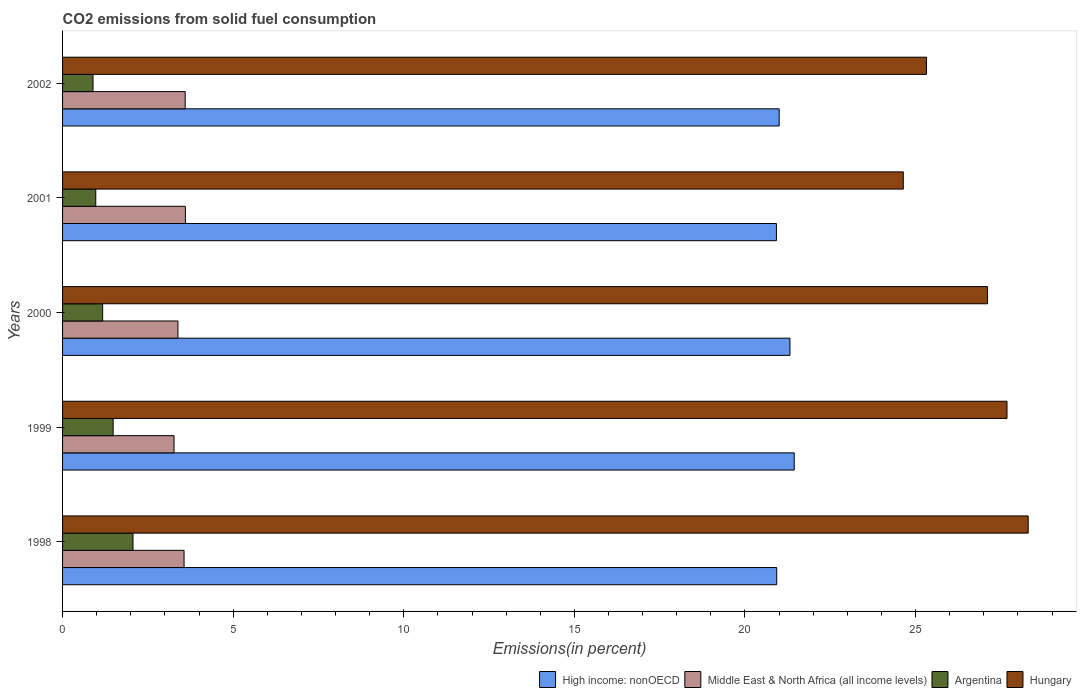In how many cases, is the number of bars for a given year not equal to the number of legend labels?
Offer a very short reply. 0. What is the total CO2 emitted in Argentina in 1998?
Offer a terse response. 2.06. Across all years, what is the maximum total CO2 emitted in Hungary?
Ensure brevity in your answer.  28.3. Across all years, what is the minimum total CO2 emitted in Middle East & North Africa (all income levels)?
Keep it short and to the point. 3.27. In which year was the total CO2 emitted in Argentina maximum?
Ensure brevity in your answer.  1998. In which year was the total CO2 emitted in Middle East & North Africa (all income levels) minimum?
Provide a succinct answer. 1999. What is the total total CO2 emitted in Hungary in the graph?
Offer a very short reply. 133.05. What is the difference between the total CO2 emitted in Hungary in 1998 and that in 2000?
Provide a succinct answer. 1.19. What is the difference between the total CO2 emitted in High income: nonOECD in 1999 and the total CO2 emitted in Middle East & North Africa (all income levels) in 2002?
Your answer should be very brief. 17.85. What is the average total CO2 emitted in Middle East & North Africa (all income levels) per year?
Your answer should be very brief. 3.48. In the year 1998, what is the difference between the total CO2 emitted in Middle East & North Africa (all income levels) and total CO2 emitted in Argentina?
Offer a very short reply. 1.5. In how many years, is the total CO2 emitted in Middle East & North Africa (all income levels) greater than 11 %?
Your answer should be compact. 0. What is the ratio of the total CO2 emitted in Argentina in 1998 to that in 2001?
Your answer should be very brief. 2.12. Is the total CO2 emitted in Argentina in 1998 less than that in 2002?
Offer a very short reply. No. What is the difference between the highest and the second highest total CO2 emitted in Middle East & North Africa (all income levels)?
Offer a terse response. 0.01. What is the difference between the highest and the lowest total CO2 emitted in High income: nonOECD?
Your response must be concise. 0.52. Is it the case that in every year, the sum of the total CO2 emitted in Hungary and total CO2 emitted in Middle East & North Africa (all income levels) is greater than the sum of total CO2 emitted in High income: nonOECD and total CO2 emitted in Argentina?
Provide a short and direct response. Yes. What does the 4th bar from the top in 2000 represents?
Offer a terse response. High income: nonOECD. What does the 2nd bar from the bottom in 1998 represents?
Offer a terse response. Middle East & North Africa (all income levels). Are all the bars in the graph horizontal?
Make the answer very short. Yes. How many years are there in the graph?
Offer a very short reply. 5. Are the values on the major ticks of X-axis written in scientific E-notation?
Your answer should be very brief. No. Does the graph contain any zero values?
Keep it short and to the point. No. Does the graph contain grids?
Provide a short and direct response. No. How many legend labels are there?
Your response must be concise. 4. What is the title of the graph?
Your answer should be very brief. CO2 emissions from solid fuel consumption. What is the label or title of the X-axis?
Provide a succinct answer. Emissions(in percent). What is the Emissions(in percent) of High income: nonOECD in 1998?
Provide a short and direct response. 20.93. What is the Emissions(in percent) of Middle East & North Africa (all income levels) in 1998?
Provide a succinct answer. 3.56. What is the Emissions(in percent) in Argentina in 1998?
Offer a terse response. 2.06. What is the Emissions(in percent) in Hungary in 1998?
Keep it short and to the point. 28.3. What is the Emissions(in percent) of High income: nonOECD in 1999?
Give a very brief answer. 21.44. What is the Emissions(in percent) of Middle East & North Africa (all income levels) in 1999?
Ensure brevity in your answer.  3.27. What is the Emissions(in percent) in Argentina in 1999?
Offer a very short reply. 1.48. What is the Emissions(in percent) of Hungary in 1999?
Offer a very short reply. 27.68. What is the Emissions(in percent) in High income: nonOECD in 2000?
Provide a succinct answer. 21.32. What is the Emissions(in percent) of Middle East & North Africa (all income levels) in 2000?
Your answer should be very brief. 3.38. What is the Emissions(in percent) in Argentina in 2000?
Ensure brevity in your answer.  1.17. What is the Emissions(in percent) of Hungary in 2000?
Keep it short and to the point. 27.11. What is the Emissions(in percent) in High income: nonOECD in 2001?
Offer a terse response. 20.92. What is the Emissions(in percent) in Middle East & North Africa (all income levels) in 2001?
Make the answer very short. 3.6. What is the Emissions(in percent) in Argentina in 2001?
Give a very brief answer. 0.97. What is the Emissions(in percent) of Hungary in 2001?
Offer a very short reply. 24.64. What is the Emissions(in percent) in High income: nonOECD in 2002?
Offer a terse response. 21. What is the Emissions(in percent) in Middle East & North Africa (all income levels) in 2002?
Give a very brief answer. 3.59. What is the Emissions(in percent) of Argentina in 2002?
Offer a terse response. 0.89. What is the Emissions(in percent) in Hungary in 2002?
Ensure brevity in your answer.  25.32. Across all years, what is the maximum Emissions(in percent) in High income: nonOECD?
Provide a succinct answer. 21.44. Across all years, what is the maximum Emissions(in percent) in Middle East & North Africa (all income levels)?
Offer a very short reply. 3.6. Across all years, what is the maximum Emissions(in percent) of Argentina?
Make the answer very short. 2.06. Across all years, what is the maximum Emissions(in percent) in Hungary?
Provide a succinct answer. 28.3. Across all years, what is the minimum Emissions(in percent) of High income: nonOECD?
Your answer should be compact. 20.92. Across all years, what is the minimum Emissions(in percent) of Middle East & North Africa (all income levels)?
Give a very brief answer. 3.27. Across all years, what is the minimum Emissions(in percent) of Argentina?
Ensure brevity in your answer.  0.89. Across all years, what is the minimum Emissions(in percent) of Hungary?
Provide a short and direct response. 24.64. What is the total Emissions(in percent) in High income: nonOECD in the graph?
Ensure brevity in your answer.  105.61. What is the total Emissions(in percent) of Middle East & North Africa (all income levels) in the graph?
Offer a terse response. 17.4. What is the total Emissions(in percent) of Argentina in the graph?
Provide a succinct answer. 6.59. What is the total Emissions(in percent) in Hungary in the graph?
Your response must be concise. 133.05. What is the difference between the Emissions(in percent) in High income: nonOECD in 1998 and that in 1999?
Your response must be concise. -0.51. What is the difference between the Emissions(in percent) in Middle East & North Africa (all income levels) in 1998 and that in 1999?
Offer a terse response. 0.29. What is the difference between the Emissions(in percent) of Argentina in 1998 and that in 1999?
Offer a very short reply. 0.58. What is the difference between the Emissions(in percent) in Hungary in 1998 and that in 1999?
Your response must be concise. 0.62. What is the difference between the Emissions(in percent) of High income: nonOECD in 1998 and that in 2000?
Give a very brief answer. -0.39. What is the difference between the Emissions(in percent) in Middle East & North Africa (all income levels) in 1998 and that in 2000?
Offer a terse response. 0.18. What is the difference between the Emissions(in percent) in Argentina in 1998 and that in 2000?
Give a very brief answer. 0.89. What is the difference between the Emissions(in percent) of Hungary in 1998 and that in 2000?
Offer a terse response. 1.19. What is the difference between the Emissions(in percent) of High income: nonOECD in 1998 and that in 2001?
Make the answer very short. 0.01. What is the difference between the Emissions(in percent) in Middle East & North Africa (all income levels) in 1998 and that in 2001?
Offer a terse response. -0.04. What is the difference between the Emissions(in percent) in Argentina in 1998 and that in 2001?
Ensure brevity in your answer.  1.09. What is the difference between the Emissions(in percent) in Hungary in 1998 and that in 2001?
Provide a succinct answer. 3.66. What is the difference between the Emissions(in percent) of High income: nonOECD in 1998 and that in 2002?
Make the answer very short. -0.07. What is the difference between the Emissions(in percent) of Middle East & North Africa (all income levels) in 1998 and that in 2002?
Give a very brief answer. -0.03. What is the difference between the Emissions(in percent) in Argentina in 1998 and that in 2002?
Your response must be concise. 1.17. What is the difference between the Emissions(in percent) in Hungary in 1998 and that in 2002?
Keep it short and to the point. 2.98. What is the difference between the Emissions(in percent) of High income: nonOECD in 1999 and that in 2000?
Your answer should be very brief. 0.13. What is the difference between the Emissions(in percent) of Middle East & North Africa (all income levels) in 1999 and that in 2000?
Your answer should be compact. -0.11. What is the difference between the Emissions(in percent) in Argentina in 1999 and that in 2000?
Keep it short and to the point. 0.31. What is the difference between the Emissions(in percent) in Hungary in 1999 and that in 2000?
Make the answer very short. 0.57. What is the difference between the Emissions(in percent) of High income: nonOECD in 1999 and that in 2001?
Provide a short and direct response. 0.52. What is the difference between the Emissions(in percent) in Middle East & North Africa (all income levels) in 1999 and that in 2001?
Offer a very short reply. -0.33. What is the difference between the Emissions(in percent) of Argentina in 1999 and that in 2001?
Offer a terse response. 0.51. What is the difference between the Emissions(in percent) of Hungary in 1999 and that in 2001?
Offer a very short reply. 3.04. What is the difference between the Emissions(in percent) of High income: nonOECD in 1999 and that in 2002?
Give a very brief answer. 0.44. What is the difference between the Emissions(in percent) in Middle East & North Africa (all income levels) in 1999 and that in 2002?
Provide a short and direct response. -0.33. What is the difference between the Emissions(in percent) in Argentina in 1999 and that in 2002?
Your answer should be compact. 0.59. What is the difference between the Emissions(in percent) of Hungary in 1999 and that in 2002?
Provide a succinct answer. 2.36. What is the difference between the Emissions(in percent) in High income: nonOECD in 2000 and that in 2001?
Your answer should be compact. 0.4. What is the difference between the Emissions(in percent) in Middle East & North Africa (all income levels) in 2000 and that in 2001?
Offer a very short reply. -0.22. What is the difference between the Emissions(in percent) in Argentina in 2000 and that in 2001?
Make the answer very short. 0.2. What is the difference between the Emissions(in percent) of Hungary in 2000 and that in 2001?
Give a very brief answer. 2.47. What is the difference between the Emissions(in percent) in High income: nonOECD in 2000 and that in 2002?
Keep it short and to the point. 0.32. What is the difference between the Emissions(in percent) in Middle East & North Africa (all income levels) in 2000 and that in 2002?
Your response must be concise. -0.21. What is the difference between the Emissions(in percent) in Argentina in 2000 and that in 2002?
Your answer should be compact. 0.28. What is the difference between the Emissions(in percent) of Hungary in 2000 and that in 2002?
Make the answer very short. 1.79. What is the difference between the Emissions(in percent) in High income: nonOECD in 2001 and that in 2002?
Offer a very short reply. -0.08. What is the difference between the Emissions(in percent) of Middle East & North Africa (all income levels) in 2001 and that in 2002?
Make the answer very short. 0.01. What is the difference between the Emissions(in percent) in Argentina in 2001 and that in 2002?
Give a very brief answer. 0.08. What is the difference between the Emissions(in percent) of Hungary in 2001 and that in 2002?
Ensure brevity in your answer.  -0.68. What is the difference between the Emissions(in percent) in High income: nonOECD in 1998 and the Emissions(in percent) in Middle East & North Africa (all income levels) in 1999?
Make the answer very short. 17.66. What is the difference between the Emissions(in percent) of High income: nonOECD in 1998 and the Emissions(in percent) of Argentina in 1999?
Keep it short and to the point. 19.45. What is the difference between the Emissions(in percent) in High income: nonOECD in 1998 and the Emissions(in percent) in Hungary in 1999?
Make the answer very short. -6.75. What is the difference between the Emissions(in percent) in Middle East & North Africa (all income levels) in 1998 and the Emissions(in percent) in Argentina in 1999?
Provide a short and direct response. 2.08. What is the difference between the Emissions(in percent) of Middle East & North Africa (all income levels) in 1998 and the Emissions(in percent) of Hungary in 1999?
Offer a very short reply. -24.12. What is the difference between the Emissions(in percent) of Argentina in 1998 and the Emissions(in percent) of Hungary in 1999?
Offer a terse response. -25.61. What is the difference between the Emissions(in percent) of High income: nonOECD in 1998 and the Emissions(in percent) of Middle East & North Africa (all income levels) in 2000?
Offer a terse response. 17.55. What is the difference between the Emissions(in percent) of High income: nonOECD in 1998 and the Emissions(in percent) of Argentina in 2000?
Ensure brevity in your answer.  19.75. What is the difference between the Emissions(in percent) in High income: nonOECD in 1998 and the Emissions(in percent) in Hungary in 2000?
Make the answer very short. -6.18. What is the difference between the Emissions(in percent) of Middle East & North Africa (all income levels) in 1998 and the Emissions(in percent) of Argentina in 2000?
Make the answer very short. 2.39. What is the difference between the Emissions(in percent) of Middle East & North Africa (all income levels) in 1998 and the Emissions(in percent) of Hungary in 2000?
Offer a terse response. -23.55. What is the difference between the Emissions(in percent) of Argentina in 1998 and the Emissions(in percent) of Hungary in 2000?
Your answer should be very brief. -25.04. What is the difference between the Emissions(in percent) in High income: nonOECD in 1998 and the Emissions(in percent) in Middle East & North Africa (all income levels) in 2001?
Provide a short and direct response. 17.33. What is the difference between the Emissions(in percent) of High income: nonOECD in 1998 and the Emissions(in percent) of Argentina in 2001?
Your answer should be very brief. 19.96. What is the difference between the Emissions(in percent) in High income: nonOECD in 1998 and the Emissions(in percent) in Hungary in 2001?
Provide a succinct answer. -3.71. What is the difference between the Emissions(in percent) in Middle East & North Africa (all income levels) in 1998 and the Emissions(in percent) in Argentina in 2001?
Provide a succinct answer. 2.59. What is the difference between the Emissions(in percent) in Middle East & North Africa (all income levels) in 1998 and the Emissions(in percent) in Hungary in 2001?
Ensure brevity in your answer.  -21.08. What is the difference between the Emissions(in percent) in Argentina in 1998 and the Emissions(in percent) in Hungary in 2001?
Offer a terse response. -22.58. What is the difference between the Emissions(in percent) in High income: nonOECD in 1998 and the Emissions(in percent) in Middle East & North Africa (all income levels) in 2002?
Give a very brief answer. 17.34. What is the difference between the Emissions(in percent) of High income: nonOECD in 1998 and the Emissions(in percent) of Argentina in 2002?
Ensure brevity in your answer.  20.04. What is the difference between the Emissions(in percent) of High income: nonOECD in 1998 and the Emissions(in percent) of Hungary in 2002?
Ensure brevity in your answer.  -4.39. What is the difference between the Emissions(in percent) of Middle East & North Africa (all income levels) in 1998 and the Emissions(in percent) of Argentina in 2002?
Provide a short and direct response. 2.67. What is the difference between the Emissions(in percent) of Middle East & North Africa (all income levels) in 1998 and the Emissions(in percent) of Hungary in 2002?
Your answer should be very brief. -21.76. What is the difference between the Emissions(in percent) of Argentina in 1998 and the Emissions(in percent) of Hungary in 2002?
Provide a short and direct response. -23.25. What is the difference between the Emissions(in percent) in High income: nonOECD in 1999 and the Emissions(in percent) in Middle East & North Africa (all income levels) in 2000?
Your answer should be very brief. 18.06. What is the difference between the Emissions(in percent) of High income: nonOECD in 1999 and the Emissions(in percent) of Argentina in 2000?
Your answer should be compact. 20.27. What is the difference between the Emissions(in percent) of High income: nonOECD in 1999 and the Emissions(in percent) of Hungary in 2000?
Provide a short and direct response. -5.67. What is the difference between the Emissions(in percent) in Middle East & North Africa (all income levels) in 1999 and the Emissions(in percent) in Argentina in 2000?
Give a very brief answer. 2.09. What is the difference between the Emissions(in percent) in Middle East & North Africa (all income levels) in 1999 and the Emissions(in percent) in Hungary in 2000?
Offer a very short reply. -23.84. What is the difference between the Emissions(in percent) of Argentina in 1999 and the Emissions(in percent) of Hungary in 2000?
Offer a very short reply. -25.63. What is the difference between the Emissions(in percent) of High income: nonOECD in 1999 and the Emissions(in percent) of Middle East & North Africa (all income levels) in 2001?
Make the answer very short. 17.84. What is the difference between the Emissions(in percent) in High income: nonOECD in 1999 and the Emissions(in percent) in Argentina in 2001?
Offer a terse response. 20.47. What is the difference between the Emissions(in percent) of High income: nonOECD in 1999 and the Emissions(in percent) of Hungary in 2001?
Your response must be concise. -3.2. What is the difference between the Emissions(in percent) of Middle East & North Africa (all income levels) in 1999 and the Emissions(in percent) of Argentina in 2001?
Your response must be concise. 2.29. What is the difference between the Emissions(in percent) in Middle East & North Africa (all income levels) in 1999 and the Emissions(in percent) in Hungary in 2001?
Make the answer very short. -21.37. What is the difference between the Emissions(in percent) of Argentina in 1999 and the Emissions(in percent) of Hungary in 2001?
Give a very brief answer. -23.16. What is the difference between the Emissions(in percent) of High income: nonOECD in 1999 and the Emissions(in percent) of Middle East & North Africa (all income levels) in 2002?
Your answer should be compact. 17.85. What is the difference between the Emissions(in percent) of High income: nonOECD in 1999 and the Emissions(in percent) of Argentina in 2002?
Make the answer very short. 20.55. What is the difference between the Emissions(in percent) of High income: nonOECD in 1999 and the Emissions(in percent) of Hungary in 2002?
Keep it short and to the point. -3.88. What is the difference between the Emissions(in percent) in Middle East & North Africa (all income levels) in 1999 and the Emissions(in percent) in Argentina in 2002?
Provide a short and direct response. 2.37. What is the difference between the Emissions(in percent) in Middle East & North Africa (all income levels) in 1999 and the Emissions(in percent) in Hungary in 2002?
Keep it short and to the point. -22.05. What is the difference between the Emissions(in percent) in Argentina in 1999 and the Emissions(in percent) in Hungary in 2002?
Offer a very short reply. -23.84. What is the difference between the Emissions(in percent) of High income: nonOECD in 2000 and the Emissions(in percent) of Middle East & North Africa (all income levels) in 2001?
Offer a terse response. 17.72. What is the difference between the Emissions(in percent) of High income: nonOECD in 2000 and the Emissions(in percent) of Argentina in 2001?
Offer a terse response. 20.34. What is the difference between the Emissions(in percent) in High income: nonOECD in 2000 and the Emissions(in percent) in Hungary in 2001?
Make the answer very short. -3.32. What is the difference between the Emissions(in percent) in Middle East & North Africa (all income levels) in 2000 and the Emissions(in percent) in Argentina in 2001?
Make the answer very short. 2.41. What is the difference between the Emissions(in percent) in Middle East & North Africa (all income levels) in 2000 and the Emissions(in percent) in Hungary in 2001?
Your response must be concise. -21.26. What is the difference between the Emissions(in percent) of Argentina in 2000 and the Emissions(in percent) of Hungary in 2001?
Provide a short and direct response. -23.46. What is the difference between the Emissions(in percent) in High income: nonOECD in 2000 and the Emissions(in percent) in Middle East & North Africa (all income levels) in 2002?
Your answer should be compact. 17.72. What is the difference between the Emissions(in percent) in High income: nonOECD in 2000 and the Emissions(in percent) in Argentina in 2002?
Make the answer very short. 20.43. What is the difference between the Emissions(in percent) in High income: nonOECD in 2000 and the Emissions(in percent) in Hungary in 2002?
Offer a terse response. -4. What is the difference between the Emissions(in percent) of Middle East & North Africa (all income levels) in 2000 and the Emissions(in percent) of Argentina in 2002?
Your answer should be compact. 2.49. What is the difference between the Emissions(in percent) of Middle East & North Africa (all income levels) in 2000 and the Emissions(in percent) of Hungary in 2002?
Offer a very short reply. -21.94. What is the difference between the Emissions(in percent) of Argentina in 2000 and the Emissions(in percent) of Hungary in 2002?
Your answer should be very brief. -24.14. What is the difference between the Emissions(in percent) in High income: nonOECD in 2001 and the Emissions(in percent) in Middle East & North Africa (all income levels) in 2002?
Offer a very short reply. 17.33. What is the difference between the Emissions(in percent) of High income: nonOECD in 2001 and the Emissions(in percent) of Argentina in 2002?
Offer a terse response. 20.03. What is the difference between the Emissions(in percent) in High income: nonOECD in 2001 and the Emissions(in percent) in Hungary in 2002?
Give a very brief answer. -4.4. What is the difference between the Emissions(in percent) in Middle East & North Africa (all income levels) in 2001 and the Emissions(in percent) in Argentina in 2002?
Keep it short and to the point. 2.71. What is the difference between the Emissions(in percent) of Middle East & North Africa (all income levels) in 2001 and the Emissions(in percent) of Hungary in 2002?
Make the answer very short. -21.72. What is the difference between the Emissions(in percent) in Argentina in 2001 and the Emissions(in percent) in Hungary in 2002?
Ensure brevity in your answer.  -24.35. What is the average Emissions(in percent) of High income: nonOECD per year?
Keep it short and to the point. 21.12. What is the average Emissions(in percent) of Middle East & North Africa (all income levels) per year?
Give a very brief answer. 3.48. What is the average Emissions(in percent) in Argentina per year?
Your answer should be very brief. 1.32. What is the average Emissions(in percent) of Hungary per year?
Offer a terse response. 26.61. In the year 1998, what is the difference between the Emissions(in percent) of High income: nonOECD and Emissions(in percent) of Middle East & North Africa (all income levels)?
Provide a succinct answer. 17.37. In the year 1998, what is the difference between the Emissions(in percent) in High income: nonOECD and Emissions(in percent) in Argentina?
Ensure brevity in your answer.  18.87. In the year 1998, what is the difference between the Emissions(in percent) of High income: nonOECD and Emissions(in percent) of Hungary?
Ensure brevity in your answer.  -7.37. In the year 1998, what is the difference between the Emissions(in percent) in Middle East & North Africa (all income levels) and Emissions(in percent) in Argentina?
Your response must be concise. 1.5. In the year 1998, what is the difference between the Emissions(in percent) of Middle East & North Africa (all income levels) and Emissions(in percent) of Hungary?
Give a very brief answer. -24.74. In the year 1998, what is the difference between the Emissions(in percent) in Argentina and Emissions(in percent) in Hungary?
Make the answer very short. -26.24. In the year 1999, what is the difference between the Emissions(in percent) of High income: nonOECD and Emissions(in percent) of Middle East & North Africa (all income levels)?
Provide a succinct answer. 18.18. In the year 1999, what is the difference between the Emissions(in percent) of High income: nonOECD and Emissions(in percent) of Argentina?
Your answer should be very brief. 19.96. In the year 1999, what is the difference between the Emissions(in percent) of High income: nonOECD and Emissions(in percent) of Hungary?
Ensure brevity in your answer.  -6.24. In the year 1999, what is the difference between the Emissions(in percent) of Middle East & North Africa (all income levels) and Emissions(in percent) of Argentina?
Offer a very short reply. 1.78. In the year 1999, what is the difference between the Emissions(in percent) of Middle East & North Africa (all income levels) and Emissions(in percent) of Hungary?
Provide a short and direct response. -24.41. In the year 1999, what is the difference between the Emissions(in percent) of Argentina and Emissions(in percent) of Hungary?
Ensure brevity in your answer.  -26.2. In the year 2000, what is the difference between the Emissions(in percent) of High income: nonOECD and Emissions(in percent) of Middle East & North Africa (all income levels)?
Make the answer very short. 17.94. In the year 2000, what is the difference between the Emissions(in percent) in High income: nonOECD and Emissions(in percent) in Argentina?
Make the answer very short. 20.14. In the year 2000, what is the difference between the Emissions(in percent) in High income: nonOECD and Emissions(in percent) in Hungary?
Provide a succinct answer. -5.79. In the year 2000, what is the difference between the Emissions(in percent) in Middle East & North Africa (all income levels) and Emissions(in percent) in Argentina?
Make the answer very short. 2.21. In the year 2000, what is the difference between the Emissions(in percent) of Middle East & North Africa (all income levels) and Emissions(in percent) of Hungary?
Make the answer very short. -23.73. In the year 2000, what is the difference between the Emissions(in percent) in Argentina and Emissions(in percent) in Hungary?
Make the answer very short. -25.93. In the year 2001, what is the difference between the Emissions(in percent) in High income: nonOECD and Emissions(in percent) in Middle East & North Africa (all income levels)?
Provide a short and direct response. 17.32. In the year 2001, what is the difference between the Emissions(in percent) in High income: nonOECD and Emissions(in percent) in Argentina?
Provide a succinct answer. 19.95. In the year 2001, what is the difference between the Emissions(in percent) of High income: nonOECD and Emissions(in percent) of Hungary?
Give a very brief answer. -3.72. In the year 2001, what is the difference between the Emissions(in percent) of Middle East & North Africa (all income levels) and Emissions(in percent) of Argentina?
Provide a succinct answer. 2.63. In the year 2001, what is the difference between the Emissions(in percent) in Middle East & North Africa (all income levels) and Emissions(in percent) in Hungary?
Your answer should be very brief. -21.04. In the year 2001, what is the difference between the Emissions(in percent) of Argentina and Emissions(in percent) of Hungary?
Offer a terse response. -23.67. In the year 2002, what is the difference between the Emissions(in percent) in High income: nonOECD and Emissions(in percent) in Middle East & North Africa (all income levels)?
Offer a terse response. 17.41. In the year 2002, what is the difference between the Emissions(in percent) of High income: nonOECD and Emissions(in percent) of Argentina?
Provide a succinct answer. 20.11. In the year 2002, what is the difference between the Emissions(in percent) in High income: nonOECD and Emissions(in percent) in Hungary?
Ensure brevity in your answer.  -4.32. In the year 2002, what is the difference between the Emissions(in percent) of Middle East & North Africa (all income levels) and Emissions(in percent) of Argentina?
Give a very brief answer. 2.7. In the year 2002, what is the difference between the Emissions(in percent) in Middle East & North Africa (all income levels) and Emissions(in percent) in Hungary?
Provide a short and direct response. -21.72. In the year 2002, what is the difference between the Emissions(in percent) in Argentina and Emissions(in percent) in Hungary?
Keep it short and to the point. -24.43. What is the ratio of the Emissions(in percent) in Middle East & North Africa (all income levels) in 1998 to that in 1999?
Offer a very short reply. 1.09. What is the ratio of the Emissions(in percent) of Argentina in 1998 to that in 1999?
Offer a terse response. 1.39. What is the ratio of the Emissions(in percent) in Hungary in 1998 to that in 1999?
Provide a succinct answer. 1.02. What is the ratio of the Emissions(in percent) of High income: nonOECD in 1998 to that in 2000?
Provide a succinct answer. 0.98. What is the ratio of the Emissions(in percent) in Middle East & North Africa (all income levels) in 1998 to that in 2000?
Your answer should be very brief. 1.05. What is the ratio of the Emissions(in percent) in Argentina in 1998 to that in 2000?
Your answer should be very brief. 1.76. What is the ratio of the Emissions(in percent) in Hungary in 1998 to that in 2000?
Provide a short and direct response. 1.04. What is the ratio of the Emissions(in percent) of High income: nonOECD in 1998 to that in 2001?
Your answer should be compact. 1. What is the ratio of the Emissions(in percent) in Middle East & North Africa (all income levels) in 1998 to that in 2001?
Make the answer very short. 0.99. What is the ratio of the Emissions(in percent) of Argentina in 1998 to that in 2001?
Make the answer very short. 2.12. What is the ratio of the Emissions(in percent) of Hungary in 1998 to that in 2001?
Offer a very short reply. 1.15. What is the ratio of the Emissions(in percent) in Middle East & North Africa (all income levels) in 1998 to that in 2002?
Make the answer very short. 0.99. What is the ratio of the Emissions(in percent) of Argentina in 1998 to that in 2002?
Ensure brevity in your answer.  2.31. What is the ratio of the Emissions(in percent) in Hungary in 1998 to that in 2002?
Your response must be concise. 1.12. What is the ratio of the Emissions(in percent) in High income: nonOECD in 1999 to that in 2000?
Ensure brevity in your answer.  1.01. What is the ratio of the Emissions(in percent) in Middle East & North Africa (all income levels) in 1999 to that in 2000?
Keep it short and to the point. 0.97. What is the ratio of the Emissions(in percent) of Argentina in 1999 to that in 2000?
Offer a terse response. 1.26. What is the ratio of the Emissions(in percent) of High income: nonOECD in 1999 to that in 2001?
Provide a short and direct response. 1.02. What is the ratio of the Emissions(in percent) in Middle East & North Africa (all income levels) in 1999 to that in 2001?
Offer a very short reply. 0.91. What is the ratio of the Emissions(in percent) in Argentina in 1999 to that in 2001?
Provide a short and direct response. 1.52. What is the ratio of the Emissions(in percent) of Hungary in 1999 to that in 2001?
Your response must be concise. 1.12. What is the ratio of the Emissions(in percent) in High income: nonOECD in 1999 to that in 2002?
Give a very brief answer. 1.02. What is the ratio of the Emissions(in percent) in Middle East & North Africa (all income levels) in 1999 to that in 2002?
Provide a succinct answer. 0.91. What is the ratio of the Emissions(in percent) of Argentina in 1999 to that in 2002?
Offer a terse response. 1.66. What is the ratio of the Emissions(in percent) in Hungary in 1999 to that in 2002?
Offer a very short reply. 1.09. What is the ratio of the Emissions(in percent) in High income: nonOECD in 2000 to that in 2001?
Provide a succinct answer. 1.02. What is the ratio of the Emissions(in percent) of Middle East & North Africa (all income levels) in 2000 to that in 2001?
Give a very brief answer. 0.94. What is the ratio of the Emissions(in percent) of Argentina in 2000 to that in 2001?
Give a very brief answer. 1.21. What is the ratio of the Emissions(in percent) of Hungary in 2000 to that in 2001?
Offer a very short reply. 1.1. What is the ratio of the Emissions(in percent) in Middle East & North Africa (all income levels) in 2000 to that in 2002?
Keep it short and to the point. 0.94. What is the ratio of the Emissions(in percent) in Argentina in 2000 to that in 2002?
Ensure brevity in your answer.  1.32. What is the ratio of the Emissions(in percent) of Hungary in 2000 to that in 2002?
Provide a short and direct response. 1.07. What is the ratio of the Emissions(in percent) of Argentina in 2001 to that in 2002?
Your answer should be very brief. 1.09. What is the ratio of the Emissions(in percent) in Hungary in 2001 to that in 2002?
Make the answer very short. 0.97. What is the difference between the highest and the second highest Emissions(in percent) in High income: nonOECD?
Provide a short and direct response. 0.13. What is the difference between the highest and the second highest Emissions(in percent) of Middle East & North Africa (all income levels)?
Offer a terse response. 0.01. What is the difference between the highest and the second highest Emissions(in percent) of Argentina?
Provide a succinct answer. 0.58. What is the difference between the highest and the second highest Emissions(in percent) in Hungary?
Ensure brevity in your answer.  0.62. What is the difference between the highest and the lowest Emissions(in percent) in High income: nonOECD?
Your response must be concise. 0.52. What is the difference between the highest and the lowest Emissions(in percent) of Middle East & North Africa (all income levels)?
Provide a succinct answer. 0.33. What is the difference between the highest and the lowest Emissions(in percent) of Argentina?
Offer a very short reply. 1.17. What is the difference between the highest and the lowest Emissions(in percent) of Hungary?
Your answer should be compact. 3.66. 